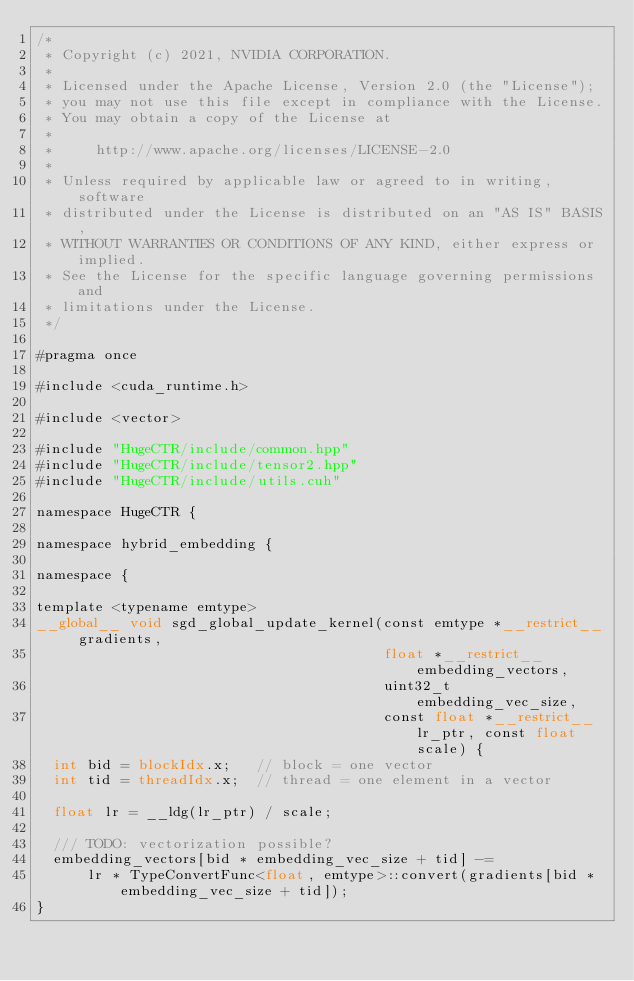Convert code to text. <code><loc_0><loc_0><loc_500><loc_500><_Cuda_>/*
 * Copyright (c) 2021, NVIDIA CORPORATION.
 *
 * Licensed under the Apache License, Version 2.0 (the "License");
 * you may not use this file except in compliance with the License.
 * You may obtain a copy of the License at
 *
 *     http://www.apache.org/licenses/LICENSE-2.0
 *
 * Unless required by applicable law or agreed to in writing, software
 * distributed under the License is distributed on an "AS IS" BASIS,
 * WITHOUT WARRANTIES OR CONDITIONS OF ANY KIND, either express or implied.
 * See the License for the specific language governing permissions and
 * limitations under the License.
 */

#pragma once

#include <cuda_runtime.h>

#include <vector>

#include "HugeCTR/include/common.hpp"
#include "HugeCTR/include/tensor2.hpp"
#include "HugeCTR/include/utils.cuh"

namespace HugeCTR {

namespace hybrid_embedding {

namespace {

template <typename emtype>
__global__ void sgd_global_update_kernel(const emtype *__restrict__ gradients,
                                         float *__restrict__ embedding_vectors,
                                         uint32_t embedding_vec_size,
                                         const float *__restrict__ lr_ptr, const float scale) {
  int bid = blockIdx.x;   // block = one vector
  int tid = threadIdx.x;  // thread = one element in a vector

  float lr = __ldg(lr_ptr) / scale;

  /// TODO: vectorization possible?
  embedding_vectors[bid * embedding_vec_size + tid] -=
      lr * TypeConvertFunc<float, emtype>::convert(gradients[bid * embedding_vec_size + tid]);
}
</code> 